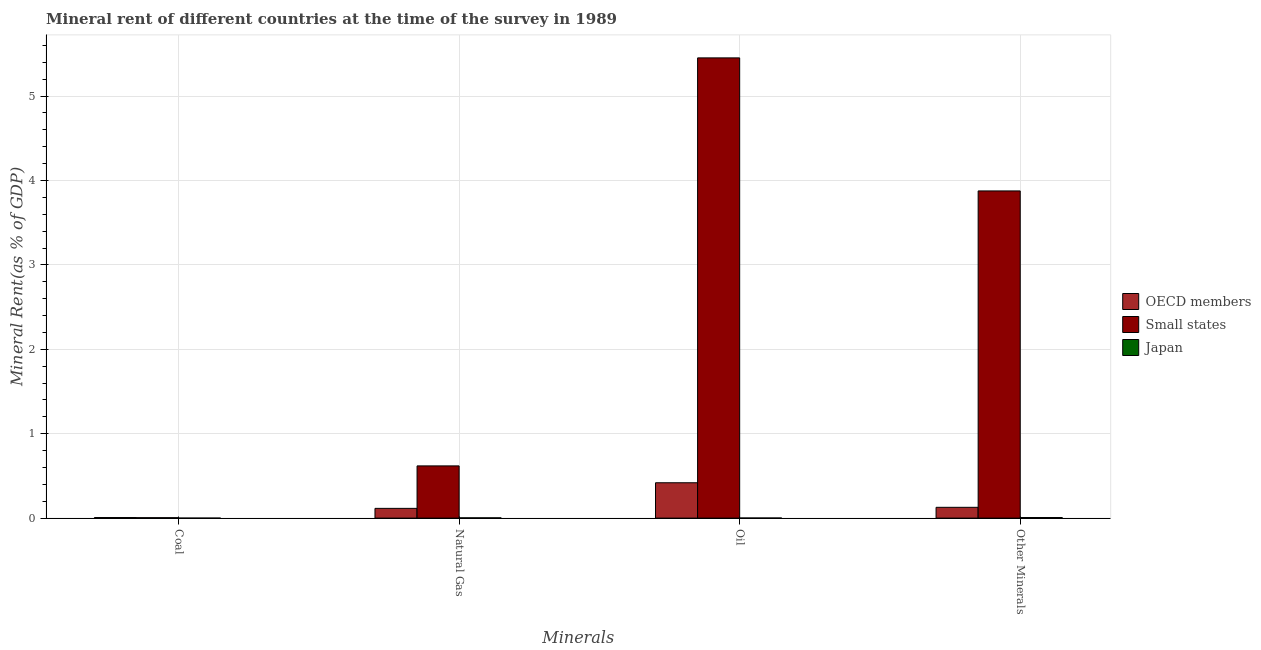How many groups of bars are there?
Your answer should be very brief. 4. Are the number of bars per tick equal to the number of legend labels?
Make the answer very short. Yes. How many bars are there on the 4th tick from the left?
Offer a very short reply. 3. What is the label of the 4th group of bars from the left?
Offer a terse response. Other Minerals. What is the  rent of other minerals in Small states?
Make the answer very short. 3.88. Across all countries, what is the maximum  rent of other minerals?
Provide a succinct answer. 3.88. Across all countries, what is the minimum  rent of other minerals?
Your answer should be very brief. 0.01. In which country was the  rent of other minerals maximum?
Your answer should be compact. Small states. What is the total  rent of other minerals in the graph?
Provide a short and direct response. 4.01. What is the difference between the natural gas rent in OECD members and that in Japan?
Offer a very short reply. 0.11. What is the difference between the  rent of other minerals in Japan and the coal rent in OECD members?
Offer a terse response. 8.139487303208091e-5. What is the average coal rent per country?
Your response must be concise. 0. What is the difference between the coal rent and natural gas rent in Small states?
Give a very brief answer. -0.61. What is the ratio of the  rent of other minerals in Japan to that in Small states?
Provide a short and direct response. 0. Is the  rent of other minerals in Japan less than that in Small states?
Offer a very short reply. Yes. Is the difference between the oil rent in Japan and OECD members greater than the difference between the natural gas rent in Japan and OECD members?
Offer a terse response. No. What is the difference between the highest and the second highest natural gas rent?
Provide a short and direct response. 0.5. What is the difference between the highest and the lowest  rent of other minerals?
Your response must be concise. 3.87. In how many countries, is the oil rent greater than the average oil rent taken over all countries?
Make the answer very short. 1. Is the sum of the natural gas rent in OECD members and Japan greater than the maximum  rent of other minerals across all countries?
Offer a very short reply. No. Is it the case that in every country, the sum of the  rent of other minerals and oil rent is greater than the sum of coal rent and natural gas rent?
Provide a short and direct response. No. What does the 2nd bar from the right in Natural Gas represents?
Give a very brief answer. Small states. Are all the bars in the graph horizontal?
Your answer should be very brief. No. What is the difference between two consecutive major ticks on the Y-axis?
Provide a short and direct response. 1. Are the values on the major ticks of Y-axis written in scientific E-notation?
Provide a succinct answer. No. Does the graph contain any zero values?
Ensure brevity in your answer.  No. What is the title of the graph?
Provide a succinct answer. Mineral rent of different countries at the time of the survey in 1989. Does "Malaysia" appear as one of the legend labels in the graph?
Provide a short and direct response. No. What is the label or title of the X-axis?
Offer a very short reply. Minerals. What is the label or title of the Y-axis?
Your response must be concise. Mineral Rent(as % of GDP). What is the Mineral Rent(as % of GDP) of OECD members in Coal?
Offer a very short reply. 0.01. What is the Mineral Rent(as % of GDP) of Small states in Coal?
Keep it short and to the point. 0.01. What is the Mineral Rent(as % of GDP) of Japan in Coal?
Provide a succinct answer. 1.52673685827782e-6. What is the Mineral Rent(as % of GDP) in OECD members in Natural Gas?
Ensure brevity in your answer.  0.12. What is the Mineral Rent(as % of GDP) in Small states in Natural Gas?
Your response must be concise. 0.62. What is the Mineral Rent(as % of GDP) of Japan in Natural Gas?
Offer a very short reply. 0. What is the Mineral Rent(as % of GDP) of OECD members in Oil?
Keep it short and to the point. 0.42. What is the Mineral Rent(as % of GDP) of Small states in Oil?
Provide a succinct answer. 5.45. What is the Mineral Rent(as % of GDP) in Japan in Oil?
Your response must be concise. 0. What is the Mineral Rent(as % of GDP) of OECD members in Other Minerals?
Ensure brevity in your answer.  0.13. What is the Mineral Rent(as % of GDP) in Small states in Other Minerals?
Keep it short and to the point. 3.88. What is the Mineral Rent(as % of GDP) in Japan in Other Minerals?
Give a very brief answer. 0.01. Across all Minerals, what is the maximum Mineral Rent(as % of GDP) in OECD members?
Your answer should be compact. 0.42. Across all Minerals, what is the maximum Mineral Rent(as % of GDP) of Small states?
Make the answer very short. 5.45. Across all Minerals, what is the maximum Mineral Rent(as % of GDP) in Japan?
Make the answer very short. 0.01. Across all Minerals, what is the minimum Mineral Rent(as % of GDP) in OECD members?
Provide a succinct answer. 0.01. Across all Minerals, what is the minimum Mineral Rent(as % of GDP) in Small states?
Make the answer very short. 0.01. Across all Minerals, what is the minimum Mineral Rent(as % of GDP) in Japan?
Your answer should be very brief. 1.52673685827782e-6. What is the total Mineral Rent(as % of GDP) of OECD members in the graph?
Your answer should be compact. 0.67. What is the total Mineral Rent(as % of GDP) in Small states in the graph?
Give a very brief answer. 9.95. What is the total Mineral Rent(as % of GDP) of Japan in the graph?
Your answer should be very brief. 0.01. What is the difference between the Mineral Rent(as % of GDP) in OECD members in Coal and that in Natural Gas?
Ensure brevity in your answer.  -0.11. What is the difference between the Mineral Rent(as % of GDP) in Small states in Coal and that in Natural Gas?
Keep it short and to the point. -0.61. What is the difference between the Mineral Rent(as % of GDP) in Japan in Coal and that in Natural Gas?
Offer a very short reply. -0. What is the difference between the Mineral Rent(as % of GDP) in OECD members in Coal and that in Oil?
Provide a short and direct response. -0.41. What is the difference between the Mineral Rent(as % of GDP) of Small states in Coal and that in Oil?
Your answer should be compact. -5.45. What is the difference between the Mineral Rent(as % of GDP) in Japan in Coal and that in Oil?
Offer a terse response. -0. What is the difference between the Mineral Rent(as % of GDP) of OECD members in Coal and that in Other Minerals?
Make the answer very short. -0.12. What is the difference between the Mineral Rent(as % of GDP) of Small states in Coal and that in Other Minerals?
Offer a terse response. -3.87. What is the difference between the Mineral Rent(as % of GDP) in Japan in Coal and that in Other Minerals?
Offer a very short reply. -0.01. What is the difference between the Mineral Rent(as % of GDP) of OECD members in Natural Gas and that in Oil?
Make the answer very short. -0.3. What is the difference between the Mineral Rent(as % of GDP) of Small states in Natural Gas and that in Oil?
Your response must be concise. -4.83. What is the difference between the Mineral Rent(as % of GDP) of Japan in Natural Gas and that in Oil?
Give a very brief answer. 0. What is the difference between the Mineral Rent(as % of GDP) in OECD members in Natural Gas and that in Other Minerals?
Your answer should be very brief. -0.01. What is the difference between the Mineral Rent(as % of GDP) of Small states in Natural Gas and that in Other Minerals?
Your response must be concise. -3.26. What is the difference between the Mineral Rent(as % of GDP) in Japan in Natural Gas and that in Other Minerals?
Make the answer very short. -0. What is the difference between the Mineral Rent(as % of GDP) in OECD members in Oil and that in Other Minerals?
Provide a succinct answer. 0.29. What is the difference between the Mineral Rent(as % of GDP) of Small states in Oil and that in Other Minerals?
Provide a short and direct response. 1.58. What is the difference between the Mineral Rent(as % of GDP) in Japan in Oil and that in Other Minerals?
Ensure brevity in your answer.  -0.01. What is the difference between the Mineral Rent(as % of GDP) in OECD members in Coal and the Mineral Rent(as % of GDP) in Small states in Natural Gas?
Make the answer very short. -0.61. What is the difference between the Mineral Rent(as % of GDP) in OECD members in Coal and the Mineral Rent(as % of GDP) in Japan in Natural Gas?
Offer a very short reply. 0. What is the difference between the Mineral Rent(as % of GDP) in Small states in Coal and the Mineral Rent(as % of GDP) in Japan in Natural Gas?
Make the answer very short. 0. What is the difference between the Mineral Rent(as % of GDP) of OECD members in Coal and the Mineral Rent(as % of GDP) of Small states in Oil?
Offer a terse response. -5.45. What is the difference between the Mineral Rent(as % of GDP) in OECD members in Coal and the Mineral Rent(as % of GDP) in Japan in Oil?
Provide a short and direct response. 0.01. What is the difference between the Mineral Rent(as % of GDP) in Small states in Coal and the Mineral Rent(as % of GDP) in Japan in Oil?
Your answer should be very brief. 0. What is the difference between the Mineral Rent(as % of GDP) in OECD members in Coal and the Mineral Rent(as % of GDP) in Small states in Other Minerals?
Your response must be concise. -3.87. What is the difference between the Mineral Rent(as % of GDP) of OECD members in Coal and the Mineral Rent(as % of GDP) of Japan in Other Minerals?
Offer a very short reply. -0. What is the difference between the Mineral Rent(as % of GDP) of Small states in Coal and the Mineral Rent(as % of GDP) of Japan in Other Minerals?
Offer a terse response. -0. What is the difference between the Mineral Rent(as % of GDP) of OECD members in Natural Gas and the Mineral Rent(as % of GDP) of Small states in Oil?
Offer a very short reply. -5.34. What is the difference between the Mineral Rent(as % of GDP) in OECD members in Natural Gas and the Mineral Rent(as % of GDP) in Japan in Oil?
Offer a very short reply. 0.11. What is the difference between the Mineral Rent(as % of GDP) of Small states in Natural Gas and the Mineral Rent(as % of GDP) of Japan in Oil?
Give a very brief answer. 0.62. What is the difference between the Mineral Rent(as % of GDP) of OECD members in Natural Gas and the Mineral Rent(as % of GDP) of Small states in Other Minerals?
Provide a short and direct response. -3.76. What is the difference between the Mineral Rent(as % of GDP) in OECD members in Natural Gas and the Mineral Rent(as % of GDP) in Japan in Other Minerals?
Give a very brief answer. 0.11. What is the difference between the Mineral Rent(as % of GDP) of Small states in Natural Gas and the Mineral Rent(as % of GDP) of Japan in Other Minerals?
Provide a succinct answer. 0.61. What is the difference between the Mineral Rent(as % of GDP) of OECD members in Oil and the Mineral Rent(as % of GDP) of Small states in Other Minerals?
Your response must be concise. -3.46. What is the difference between the Mineral Rent(as % of GDP) of OECD members in Oil and the Mineral Rent(as % of GDP) of Japan in Other Minerals?
Give a very brief answer. 0.41. What is the difference between the Mineral Rent(as % of GDP) in Small states in Oil and the Mineral Rent(as % of GDP) in Japan in Other Minerals?
Keep it short and to the point. 5.45. What is the average Mineral Rent(as % of GDP) in OECD members per Minerals?
Offer a very short reply. 0.17. What is the average Mineral Rent(as % of GDP) of Small states per Minerals?
Ensure brevity in your answer.  2.49. What is the average Mineral Rent(as % of GDP) in Japan per Minerals?
Keep it short and to the point. 0. What is the difference between the Mineral Rent(as % of GDP) in OECD members and Mineral Rent(as % of GDP) in Small states in Coal?
Your response must be concise. 0. What is the difference between the Mineral Rent(as % of GDP) of OECD members and Mineral Rent(as % of GDP) of Japan in Coal?
Ensure brevity in your answer.  0.01. What is the difference between the Mineral Rent(as % of GDP) in Small states and Mineral Rent(as % of GDP) in Japan in Coal?
Provide a short and direct response. 0.01. What is the difference between the Mineral Rent(as % of GDP) of OECD members and Mineral Rent(as % of GDP) of Small states in Natural Gas?
Give a very brief answer. -0.5. What is the difference between the Mineral Rent(as % of GDP) in OECD members and Mineral Rent(as % of GDP) in Japan in Natural Gas?
Your answer should be compact. 0.11. What is the difference between the Mineral Rent(as % of GDP) in Small states and Mineral Rent(as % of GDP) in Japan in Natural Gas?
Make the answer very short. 0.62. What is the difference between the Mineral Rent(as % of GDP) of OECD members and Mineral Rent(as % of GDP) of Small states in Oil?
Provide a short and direct response. -5.03. What is the difference between the Mineral Rent(as % of GDP) in OECD members and Mineral Rent(as % of GDP) in Japan in Oil?
Make the answer very short. 0.42. What is the difference between the Mineral Rent(as % of GDP) of Small states and Mineral Rent(as % of GDP) of Japan in Oil?
Offer a terse response. 5.45. What is the difference between the Mineral Rent(as % of GDP) in OECD members and Mineral Rent(as % of GDP) in Small states in Other Minerals?
Ensure brevity in your answer.  -3.75. What is the difference between the Mineral Rent(as % of GDP) in OECD members and Mineral Rent(as % of GDP) in Japan in Other Minerals?
Provide a short and direct response. 0.12. What is the difference between the Mineral Rent(as % of GDP) of Small states and Mineral Rent(as % of GDP) of Japan in Other Minerals?
Provide a short and direct response. 3.87. What is the ratio of the Mineral Rent(as % of GDP) of OECD members in Coal to that in Natural Gas?
Ensure brevity in your answer.  0.06. What is the ratio of the Mineral Rent(as % of GDP) of Small states in Coal to that in Natural Gas?
Your answer should be very brief. 0.01. What is the ratio of the Mineral Rent(as % of GDP) in Japan in Coal to that in Natural Gas?
Your answer should be compact. 0. What is the ratio of the Mineral Rent(as % of GDP) in OECD members in Coal to that in Oil?
Offer a very short reply. 0.02. What is the ratio of the Mineral Rent(as % of GDP) in Small states in Coal to that in Oil?
Your response must be concise. 0. What is the ratio of the Mineral Rent(as % of GDP) in Japan in Coal to that in Oil?
Keep it short and to the point. 0. What is the ratio of the Mineral Rent(as % of GDP) in OECD members in Coal to that in Other Minerals?
Your answer should be very brief. 0.05. What is the ratio of the Mineral Rent(as % of GDP) of Small states in Coal to that in Other Minerals?
Your answer should be compact. 0. What is the ratio of the Mineral Rent(as % of GDP) of Japan in Coal to that in Other Minerals?
Keep it short and to the point. 0. What is the ratio of the Mineral Rent(as % of GDP) of OECD members in Natural Gas to that in Oil?
Keep it short and to the point. 0.28. What is the ratio of the Mineral Rent(as % of GDP) of Small states in Natural Gas to that in Oil?
Keep it short and to the point. 0.11. What is the ratio of the Mineral Rent(as % of GDP) in Japan in Natural Gas to that in Oil?
Give a very brief answer. 2.59. What is the ratio of the Mineral Rent(as % of GDP) of OECD members in Natural Gas to that in Other Minerals?
Your answer should be compact. 0.9. What is the ratio of the Mineral Rent(as % of GDP) in Small states in Natural Gas to that in Other Minerals?
Provide a short and direct response. 0.16. What is the ratio of the Mineral Rent(as % of GDP) of Japan in Natural Gas to that in Other Minerals?
Provide a succinct answer. 0.48. What is the ratio of the Mineral Rent(as % of GDP) of OECD members in Oil to that in Other Minerals?
Your response must be concise. 3.28. What is the ratio of the Mineral Rent(as % of GDP) in Small states in Oil to that in Other Minerals?
Offer a very short reply. 1.41. What is the ratio of the Mineral Rent(as % of GDP) of Japan in Oil to that in Other Minerals?
Your answer should be very brief. 0.19. What is the difference between the highest and the second highest Mineral Rent(as % of GDP) of OECD members?
Keep it short and to the point. 0.29. What is the difference between the highest and the second highest Mineral Rent(as % of GDP) in Small states?
Ensure brevity in your answer.  1.58. What is the difference between the highest and the second highest Mineral Rent(as % of GDP) of Japan?
Offer a very short reply. 0. What is the difference between the highest and the lowest Mineral Rent(as % of GDP) in OECD members?
Offer a terse response. 0.41. What is the difference between the highest and the lowest Mineral Rent(as % of GDP) of Small states?
Offer a terse response. 5.45. What is the difference between the highest and the lowest Mineral Rent(as % of GDP) in Japan?
Offer a terse response. 0.01. 